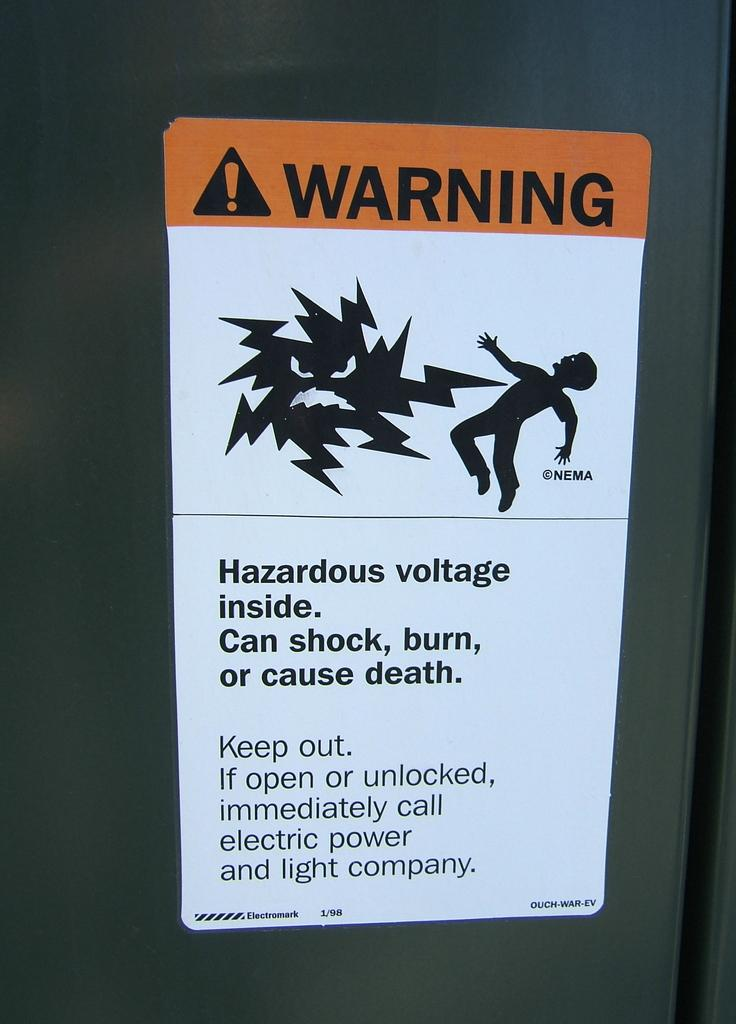What is the main object in the image? There is a blackboard in the image. What is attached to the blackboard? A white paper with text is pasted on the blackboard. How does the balance of the blackboard change during the grandmother's battle in the image? There is no mention of a balance, grandmother, or battle in the image. The image only features a blackboard with a white paper attached to it. 